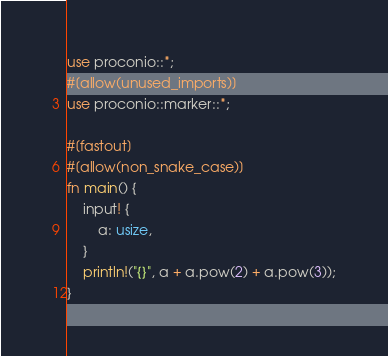Convert code to text. <code><loc_0><loc_0><loc_500><loc_500><_Rust_>use proconio::*;
#[allow(unused_imports)]
use proconio::marker::*;

#[fastout]
#[allow(non_snake_case)]
fn main() {
    input! {
        a: usize,
    }
    println!("{}", a + a.pow(2) + a.pow(3));
}
</code> 